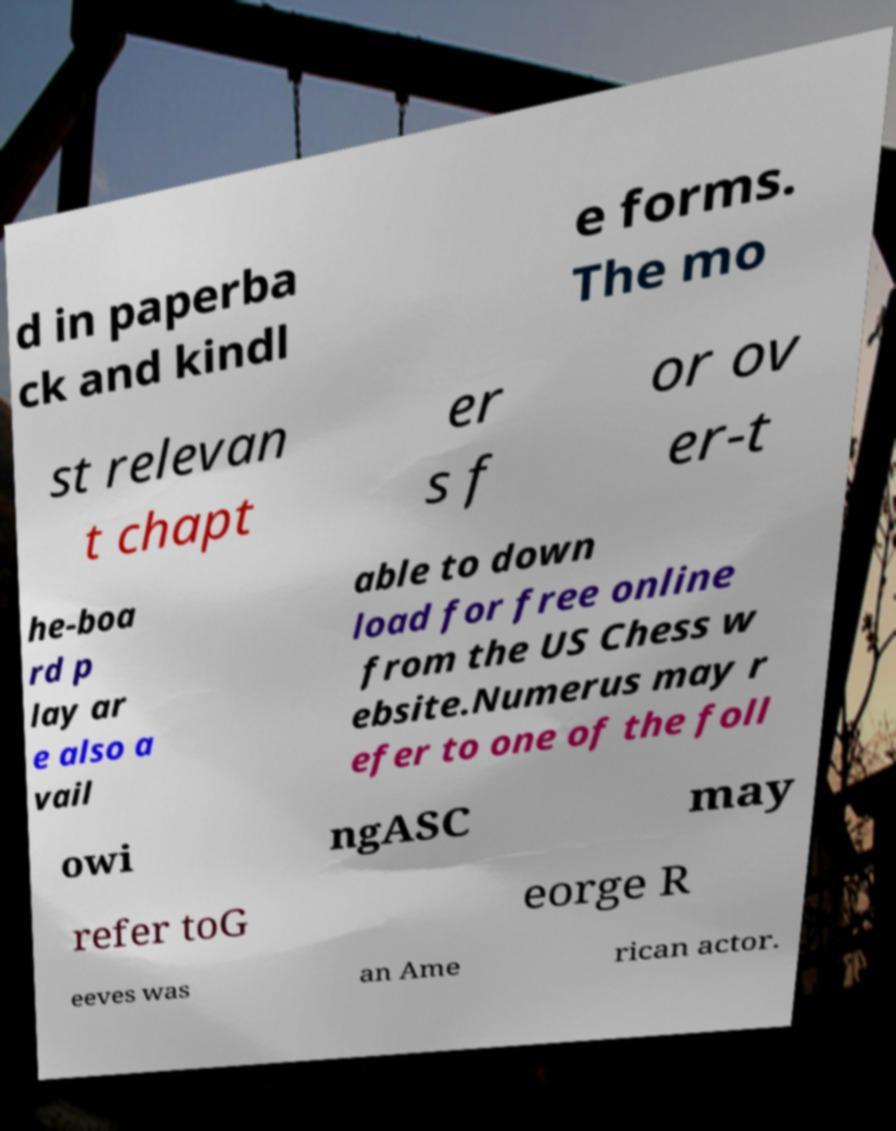What messages or text are displayed in this image? I need them in a readable, typed format. d in paperba ck and kindl e forms. The mo st relevan t chapt er s f or ov er-t he-boa rd p lay ar e also a vail able to down load for free online from the US Chess w ebsite.Numerus may r efer to one of the foll owi ngASC may refer toG eorge R eeves was an Ame rican actor. 